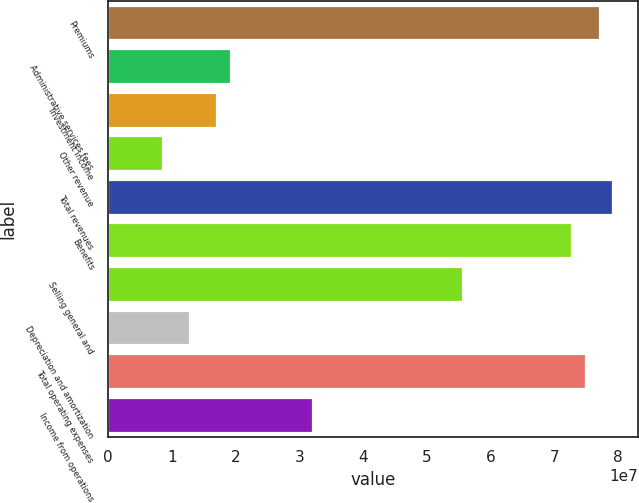Convert chart. <chart><loc_0><loc_0><loc_500><loc_500><bar_chart><fcel>Premiums<fcel>Administrative services fees<fcel>Investment income<fcel>Other revenue<fcel>Total revenues<fcel>Benefits<fcel>Selling general and<fcel>Depreciation and amortization<fcel>Total operating expenses<fcel>Income from operations<nl><fcel>7.70995e+07<fcel>1.92749e+07<fcel>1.71332e+07<fcel>8.56662e+06<fcel>7.92412e+07<fcel>7.28162e+07<fcel>5.5683e+07<fcel>1.28499e+07<fcel>7.49579e+07<fcel>3.21248e+07<nl></chart> 